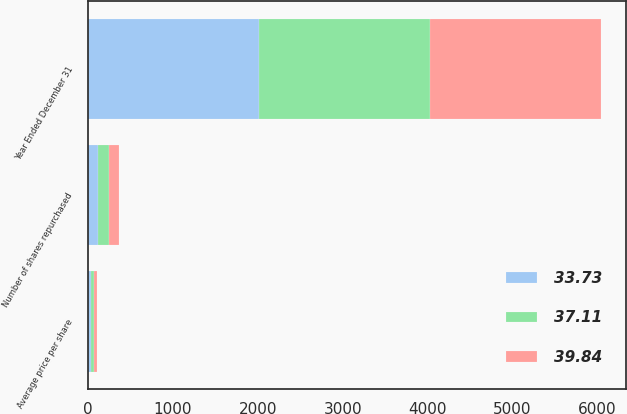Convert chart to OTSL. <chart><loc_0><loc_0><loc_500><loc_500><stacked_bar_chart><ecel><fcel>Year Ended December 31<fcel>Number of shares repurchased<fcel>Average price per share<nl><fcel>39.84<fcel>2013<fcel>121<fcel>39.84<nl><fcel>33.73<fcel>2012<fcel>121<fcel>37.11<nl><fcel>37.11<fcel>2011<fcel>127<fcel>33.73<nl></chart> 